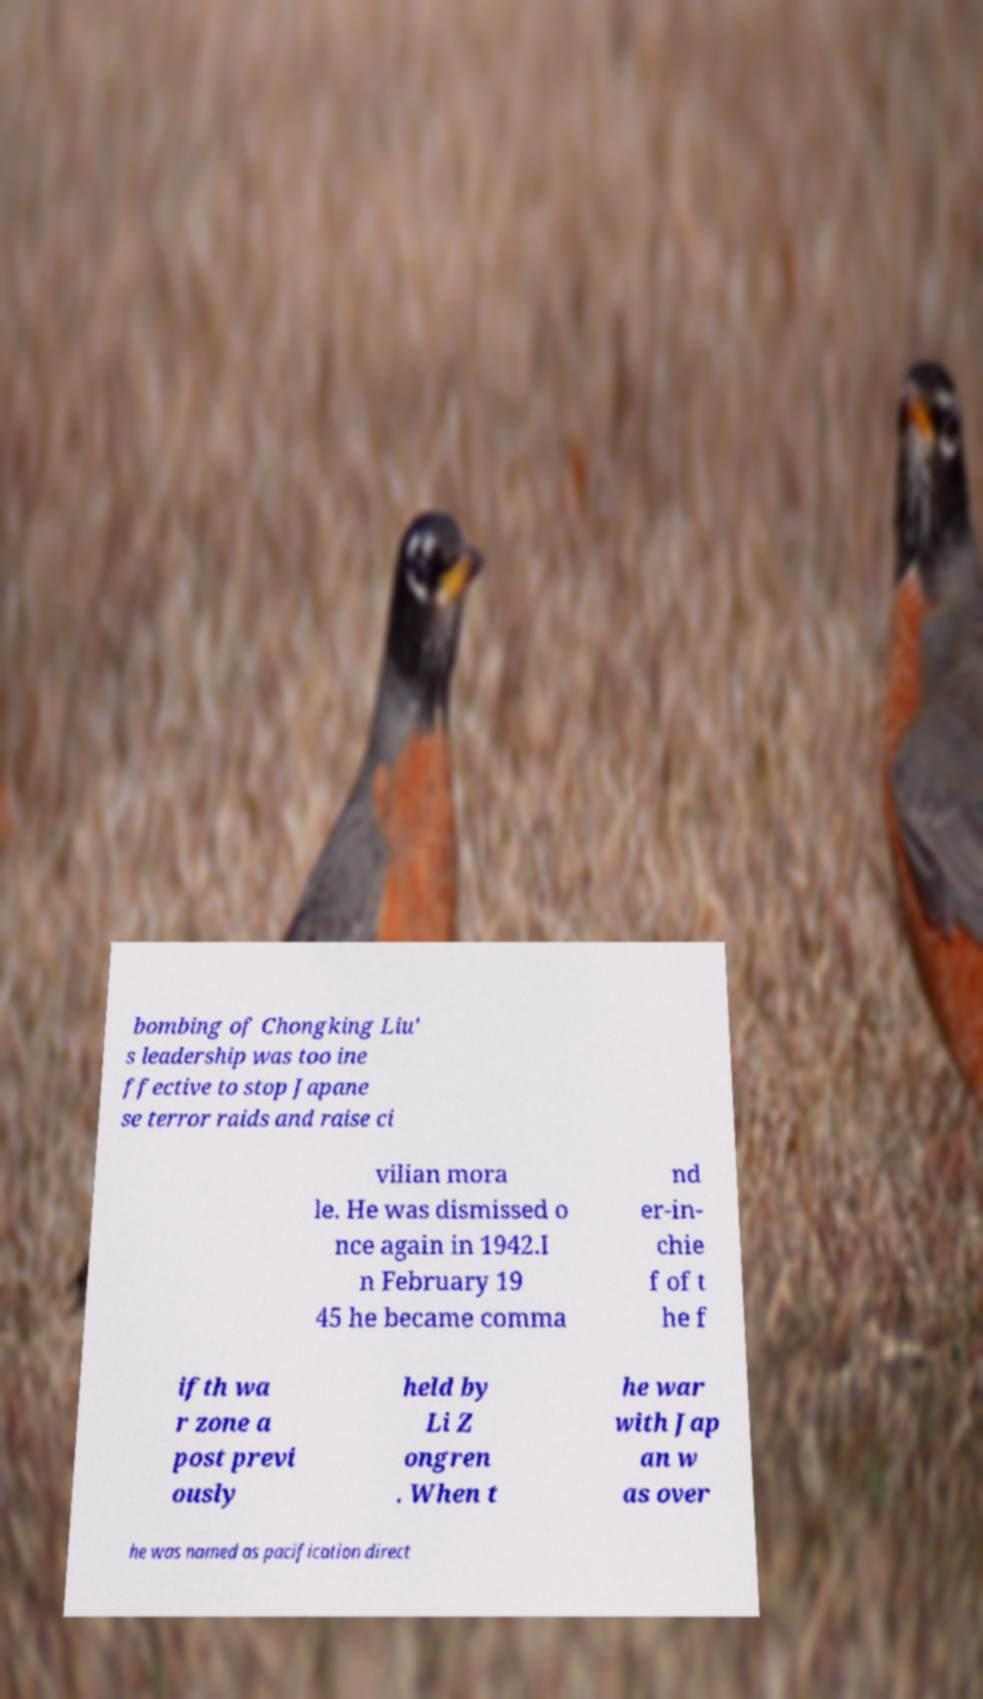Could you extract and type out the text from this image? bombing of Chongking Liu' s leadership was too ine ffective to stop Japane se terror raids and raise ci vilian mora le. He was dismissed o nce again in 1942.I n February 19 45 he became comma nd er-in- chie f of t he f ifth wa r zone a post previ ously held by Li Z ongren . When t he war with Jap an w as over he was named as pacification direct 